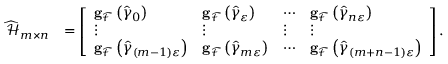Convert formula to latex. <formula><loc_0><loc_0><loc_500><loc_500>\begin{array} { r l } { \widehat { \mathcal { H } } _ { m \times n } } & { = \left [ \begin{array} { l l l l } { g _ { \mathcal { F } } \left ( \widehat { \gamma } _ { 0 } \right ) } & { g _ { \mathcal { F } } \left ( \widehat { \gamma } _ { \varepsilon } \right ) } & { \cdots } & { g _ { \mathcal { F } } \left ( \widehat { \gamma } _ { n \varepsilon } \right ) } \\ { \vdots } & { \vdots } & { \vdots } & { \vdots } \\ { g _ { \mathcal { F } } \left ( \widehat { \gamma } _ { \left ( m - 1 \right ) \varepsilon } \right ) } & { g _ { \mathcal { F } } \left ( \widehat { \gamma } _ { m \varepsilon } \right ) } & { \cdots } & { g _ { \mathcal { F } } \left ( \widehat { \gamma } _ { \left ( m + n - 1 \right ) \varepsilon } \right ) } \end{array} \right ] . } \end{array}</formula> 